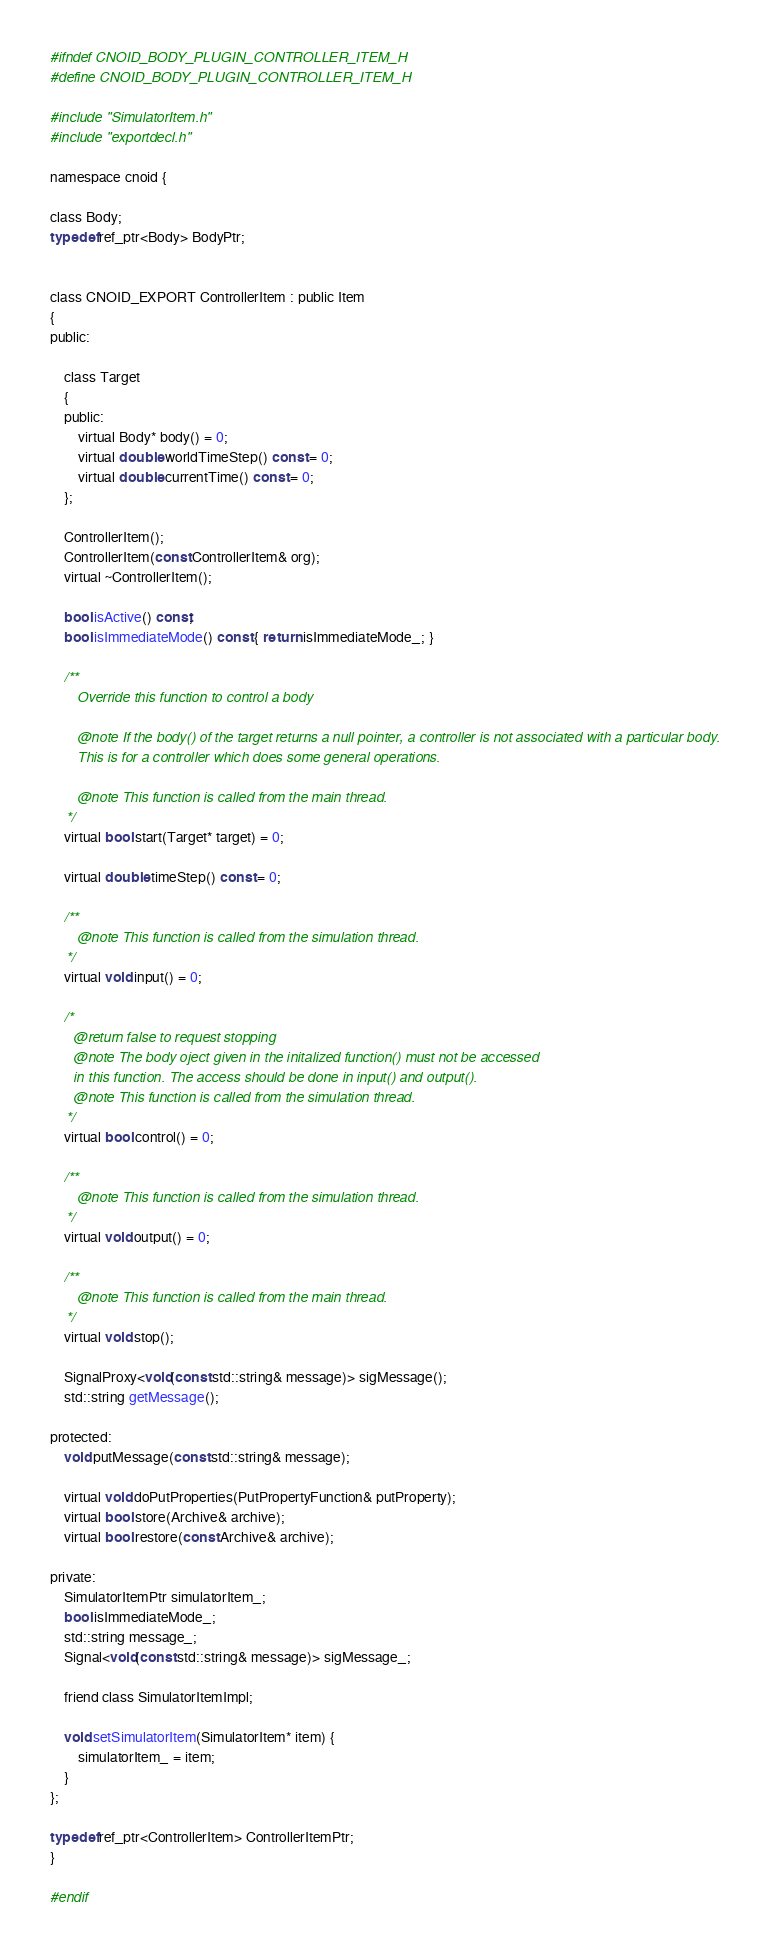Convert code to text. <code><loc_0><loc_0><loc_500><loc_500><_C_>
#ifndef CNOID_BODY_PLUGIN_CONTROLLER_ITEM_H
#define CNOID_BODY_PLUGIN_CONTROLLER_ITEM_H

#include "SimulatorItem.h"
#include "exportdecl.h"

namespace cnoid {

class Body;
typedef ref_ptr<Body> BodyPtr;

    
class CNOID_EXPORT ControllerItem : public Item
{
public:

    class Target
    {
    public:
        virtual Body* body() = 0;
        virtual double worldTimeStep() const = 0;
        virtual double currentTime() const = 0;
    };
        
    ControllerItem();
    ControllerItem(const ControllerItem& org);
    virtual ~ControllerItem();

    bool isActive() const;
    bool isImmediateMode() const { return isImmediateMode_; }

    /**
       Override this function to control a body

       @note If the body() of the target returns a null pointer, a controller is not associated with a particular body.
       This is for a controller which does some general operations.
           
       @note This function is called from the main thread.
    */
    virtual bool start(Target* target) = 0;

    virtual double timeStep() const = 0;

    /**
       @note This function is called from the simulation thread.
    */
    virtual void input() = 0;

    /*
      @return false to request stopping
      @note The body oject given in the initalized function() must not be accessed
      in this function. The access should be done in input() and output().
      @note This function is called from the simulation thread.
    */
    virtual bool control() = 0;
        
    /**
       @note This function is called from the simulation thread.
    */
    virtual void output() = 0;
        
    /**
       @note This function is called from the main thread.
    */
    virtual void stop();

    SignalProxy<void(const std::string& message)> sigMessage();
    std::string getMessage();

protected:
    void putMessage(const std::string& message);

    virtual void doPutProperties(PutPropertyFunction& putProperty);
    virtual bool store(Archive& archive);
    virtual bool restore(const Archive& archive);

private:
    SimulatorItemPtr simulatorItem_;
    bool isImmediateMode_;
    std::string message_;
    Signal<void(const std::string& message)> sigMessage_;

    friend class SimulatorItemImpl;

    void setSimulatorItem(SimulatorItem* item) {
        simulatorItem_ = item;
    }
};
        
typedef ref_ptr<ControllerItem> ControllerItemPtr;
}

#endif
</code> 